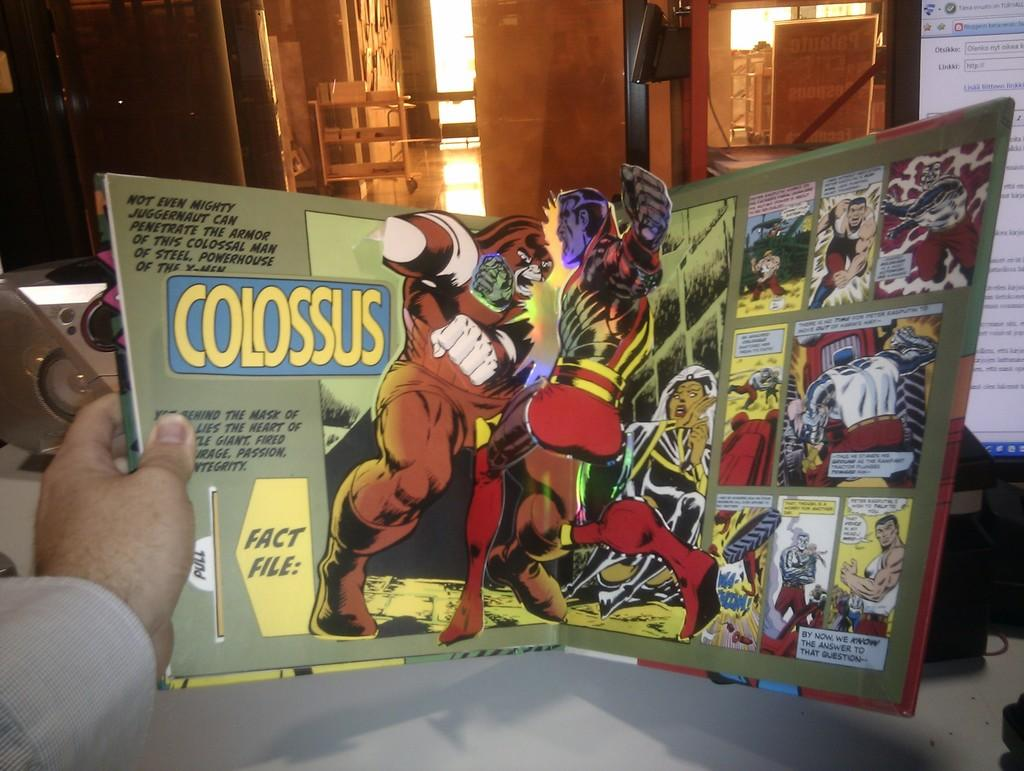<image>
Render a clear and concise summary of the photo. Two robot like figures fighting in a comic spread with the word Colossus in bold yellow letters. . 